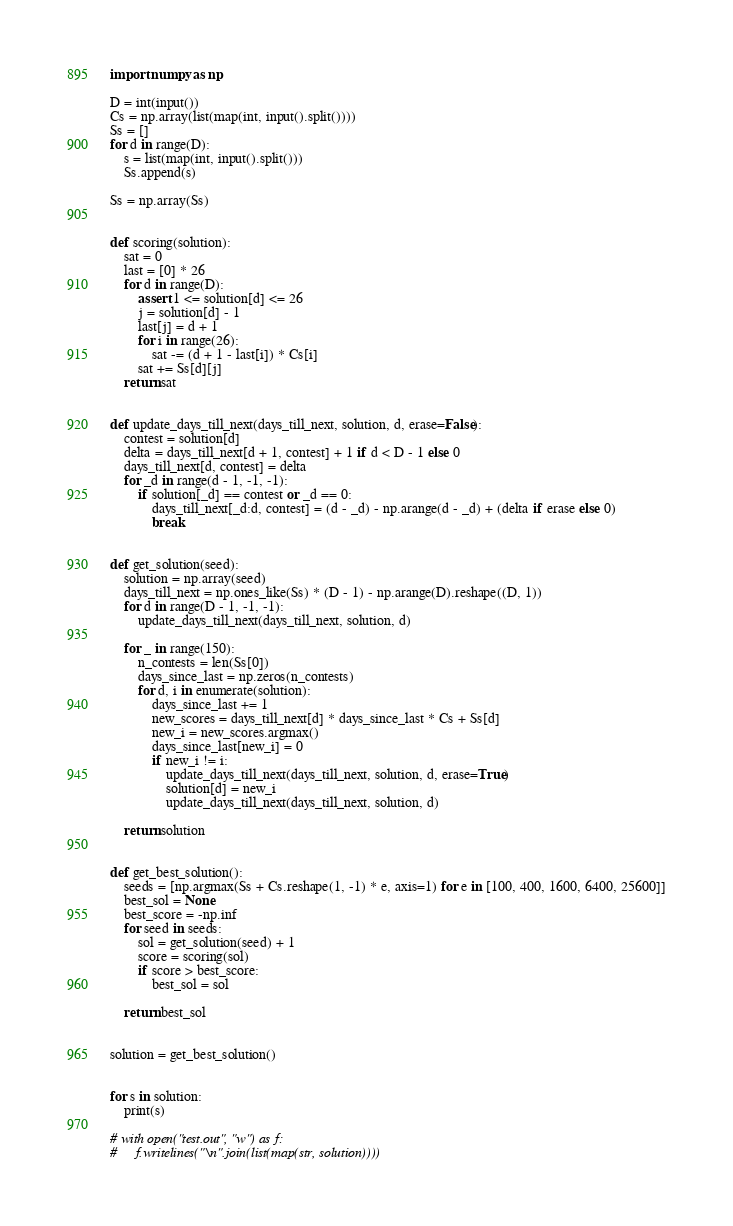<code> <loc_0><loc_0><loc_500><loc_500><_Python_>import numpy as np

D = int(input())
Cs = np.array(list(map(int, input().split())))
Ss = []
for d in range(D):
    s = list(map(int, input().split()))
    Ss.append(s)

Ss = np.array(Ss)


def scoring(solution):
    sat = 0
    last = [0] * 26
    for d in range(D):
        assert 1 <= solution[d] <= 26
        j = solution[d] - 1
        last[j] = d + 1
        for i in range(26):
            sat -= (d + 1 - last[i]) * Cs[i]
        sat += Ss[d][j]
    return sat


def update_days_till_next(days_till_next, solution, d, erase=False):
    contest = solution[d]
    delta = days_till_next[d + 1, contest] + 1 if d < D - 1 else 0
    days_till_next[d, contest] = delta
    for _d in range(d - 1, -1, -1):
        if solution[_d] == contest or _d == 0:
            days_till_next[_d:d, contest] = (d - _d) - np.arange(d - _d) + (delta if erase else 0)
            break


def get_solution(seed):
    solution = np.array(seed)
    days_till_next = np.ones_like(Ss) * (D - 1) - np.arange(D).reshape((D, 1))
    for d in range(D - 1, -1, -1):
        update_days_till_next(days_till_next, solution, d)

    for _ in range(150):
        n_contests = len(Ss[0])
        days_since_last = np.zeros(n_contests)
        for d, i in enumerate(solution):
            days_since_last += 1
            new_scores = days_till_next[d] * days_since_last * Cs + Ss[d]
            new_i = new_scores.argmax()
            days_since_last[new_i] = 0
            if new_i != i:
                update_days_till_next(days_till_next, solution, d, erase=True)
                solution[d] = new_i
                update_days_till_next(days_till_next, solution, d)

    return solution


def get_best_solution():
    seeds = [np.argmax(Ss + Cs.reshape(1, -1) * e, axis=1) for e in [100, 400, 1600, 6400, 25600]]
    best_sol = None
    best_score = -np.inf
    for seed in seeds:
        sol = get_solution(seed) + 1
        score = scoring(sol)
        if score > best_score:
            best_sol = sol

    return best_sol


solution = get_best_solution()


for s in solution:
    print(s)

# with open("test.out", "w") as f:
#     f.writelines("\n".join(list(map(str, solution))))
</code> 